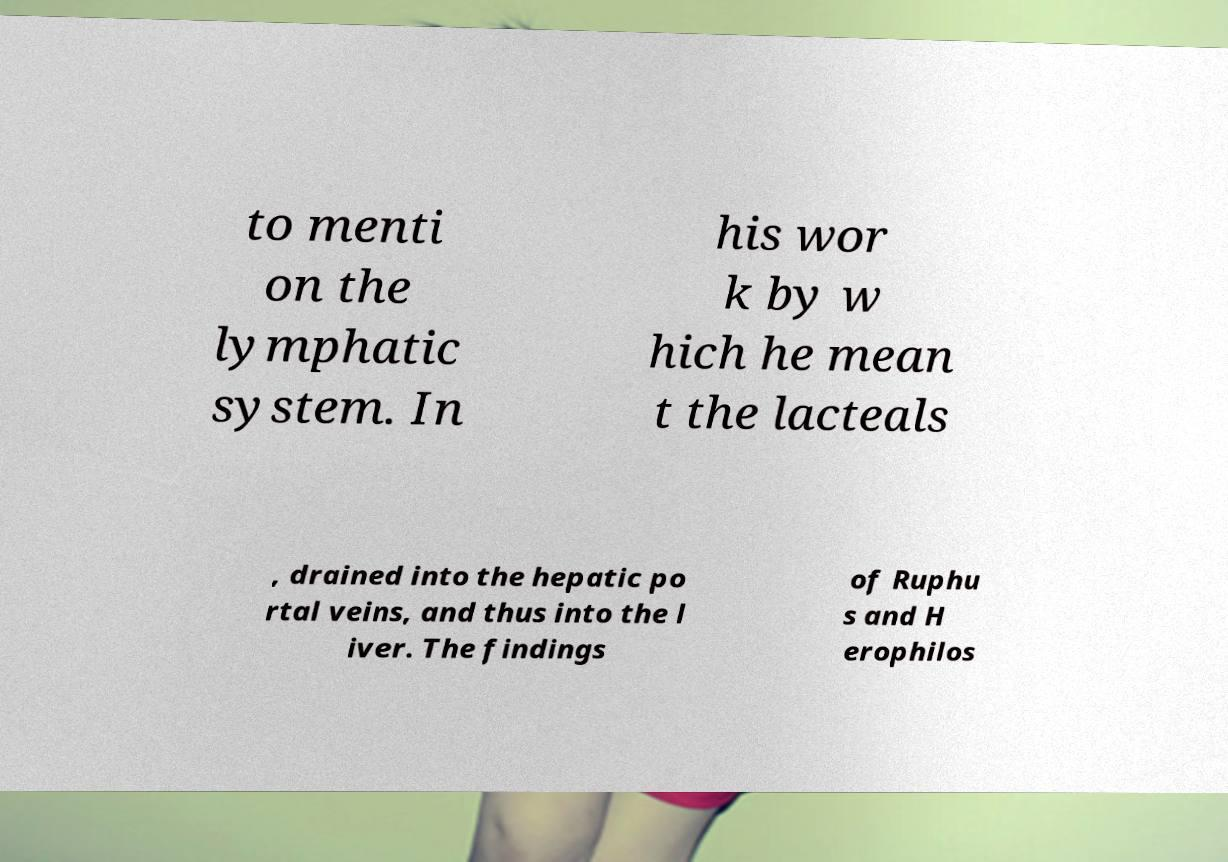What messages or text are displayed in this image? I need them in a readable, typed format. to menti on the lymphatic system. In his wor k by w hich he mean t the lacteals , drained into the hepatic po rtal veins, and thus into the l iver. The findings of Ruphu s and H erophilos 